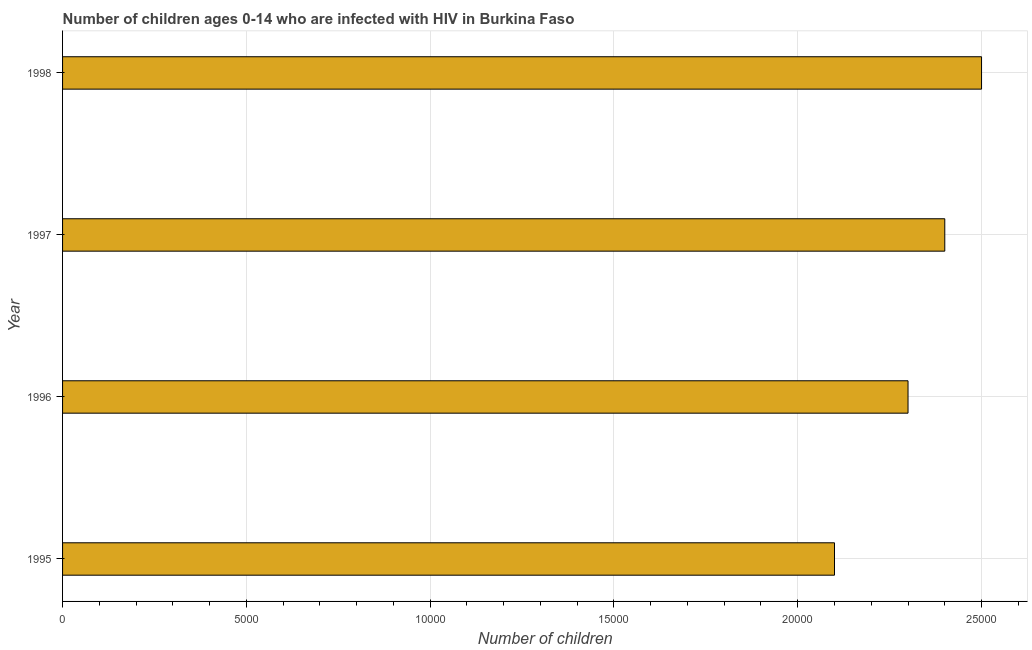What is the title of the graph?
Offer a very short reply. Number of children ages 0-14 who are infected with HIV in Burkina Faso. What is the label or title of the X-axis?
Make the answer very short. Number of children. What is the number of children living with hiv in 1998?
Your response must be concise. 2.50e+04. Across all years, what is the maximum number of children living with hiv?
Keep it short and to the point. 2.50e+04. Across all years, what is the minimum number of children living with hiv?
Keep it short and to the point. 2.10e+04. What is the sum of the number of children living with hiv?
Offer a very short reply. 9.30e+04. What is the difference between the number of children living with hiv in 1997 and 1998?
Make the answer very short. -1000. What is the average number of children living with hiv per year?
Provide a succinct answer. 2.32e+04. What is the median number of children living with hiv?
Offer a terse response. 2.35e+04. In how many years, is the number of children living with hiv greater than 12000 ?
Make the answer very short. 4. Is the number of children living with hiv in 1995 less than that in 1998?
Your answer should be compact. Yes. What is the difference between the highest and the second highest number of children living with hiv?
Offer a very short reply. 1000. Is the sum of the number of children living with hiv in 1996 and 1997 greater than the maximum number of children living with hiv across all years?
Your response must be concise. Yes. What is the difference between the highest and the lowest number of children living with hiv?
Your answer should be compact. 4000. In how many years, is the number of children living with hiv greater than the average number of children living with hiv taken over all years?
Offer a very short reply. 2. How many bars are there?
Keep it short and to the point. 4. What is the difference between two consecutive major ticks on the X-axis?
Your response must be concise. 5000. What is the Number of children in 1995?
Your answer should be compact. 2.10e+04. What is the Number of children in 1996?
Give a very brief answer. 2.30e+04. What is the Number of children of 1997?
Offer a very short reply. 2.40e+04. What is the Number of children in 1998?
Make the answer very short. 2.50e+04. What is the difference between the Number of children in 1995 and 1996?
Give a very brief answer. -2000. What is the difference between the Number of children in 1995 and 1997?
Provide a short and direct response. -3000. What is the difference between the Number of children in 1995 and 1998?
Provide a short and direct response. -4000. What is the difference between the Number of children in 1996 and 1997?
Your response must be concise. -1000. What is the difference between the Number of children in 1996 and 1998?
Your response must be concise. -2000. What is the difference between the Number of children in 1997 and 1998?
Your answer should be very brief. -1000. What is the ratio of the Number of children in 1995 to that in 1997?
Make the answer very short. 0.88. What is the ratio of the Number of children in 1995 to that in 1998?
Provide a short and direct response. 0.84. What is the ratio of the Number of children in 1996 to that in 1997?
Ensure brevity in your answer.  0.96. 